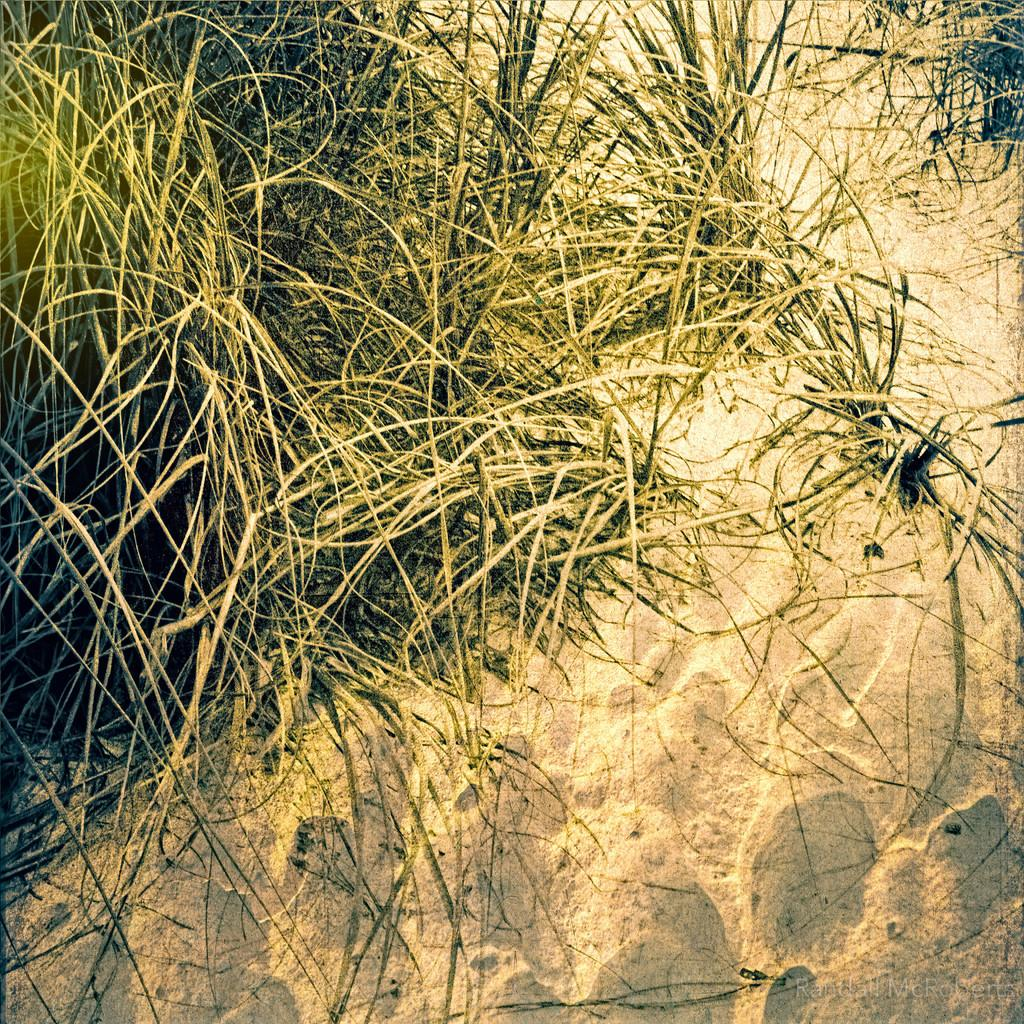What type of terrain is visible in the image? There is sand and grass visible in the image. Can you describe any other features of the image? There is a watermark on the image. Where is the nest located in the image? There is no nest present in the image. What riddle can be solved by examining the image? There is no riddle associated with the image. 